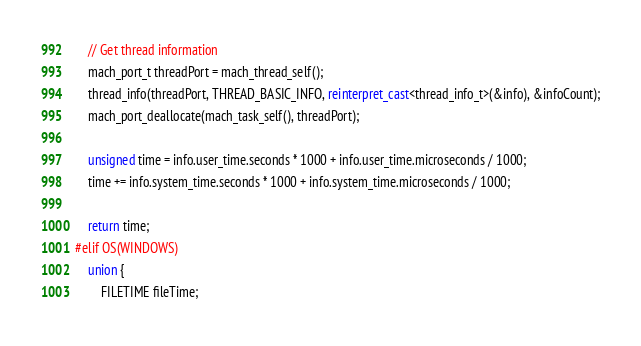Convert code to text. <code><loc_0><loc_0><loc_500><loc_500><_C++_>    // Get thread information
    mach_port_t threadPort = mach_thread_self();
    thread_info(threadPort, THREAD_BASIC_INFO, reinterpret_cast<thread_info_t>(&info), &infoCount);
    mach_port_deallocate(mach_task_self(), threadPort);
    
    unsigned time = info.user_time.seconds * 1000 + info.user_time.microseconds / 1000;
    time += info.system_time.seconds * 1000 + info.system_time.microseconds / 1000;
    
    return time;
#elif OS(WINDOWS)
    union {
        FILETIME fileTime;</code> 